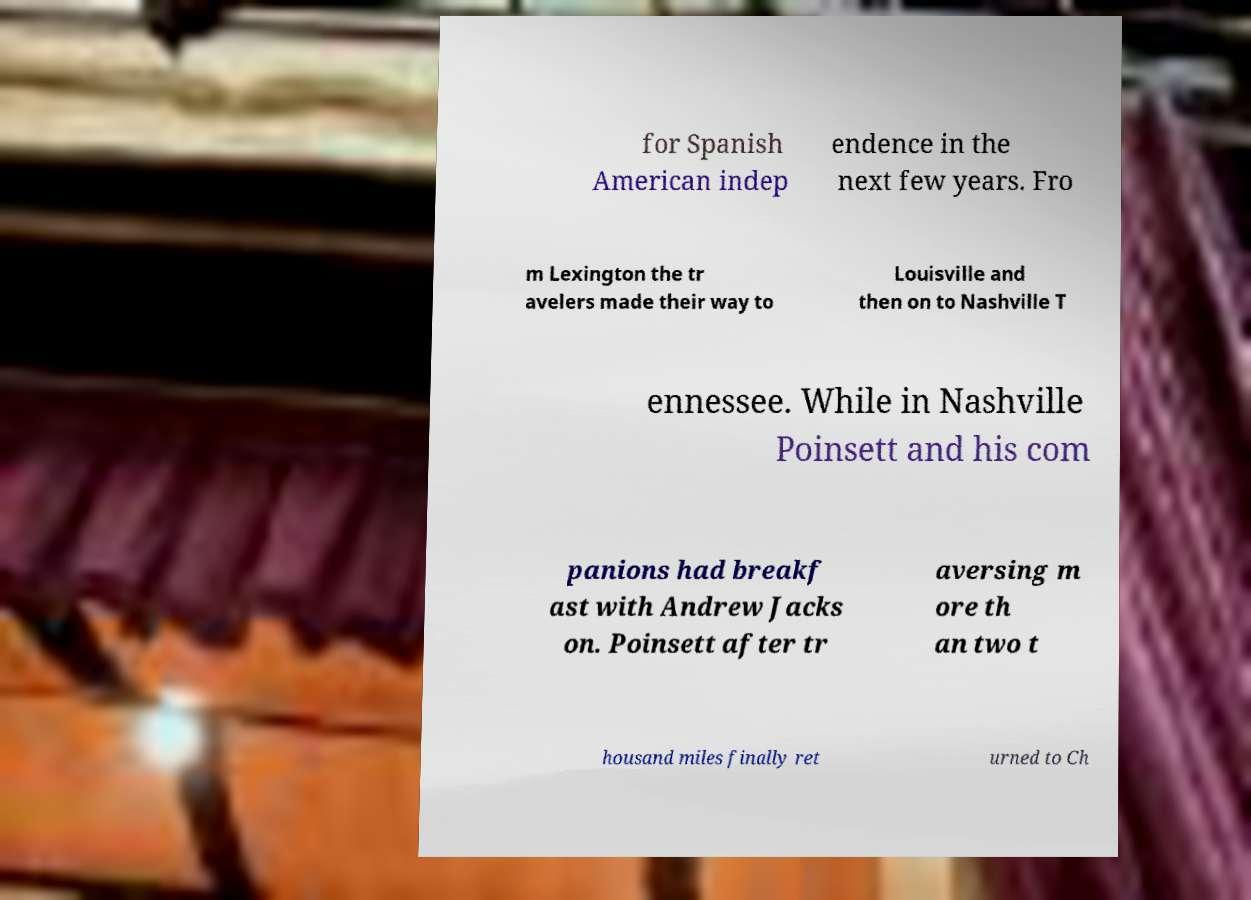Please identify and transcribe the text found in this image. for Spanish American indep endence in the next few years. Fro m Lexington the tr avelers made their way to Louisville and then on to Nashville T ennessee. While in Nashville Poinsett and his com panions had breakf ast with Andrew Jacks on. Poinsett after tr aversing m ore th an two t housand miles finally ret urned to Ch 